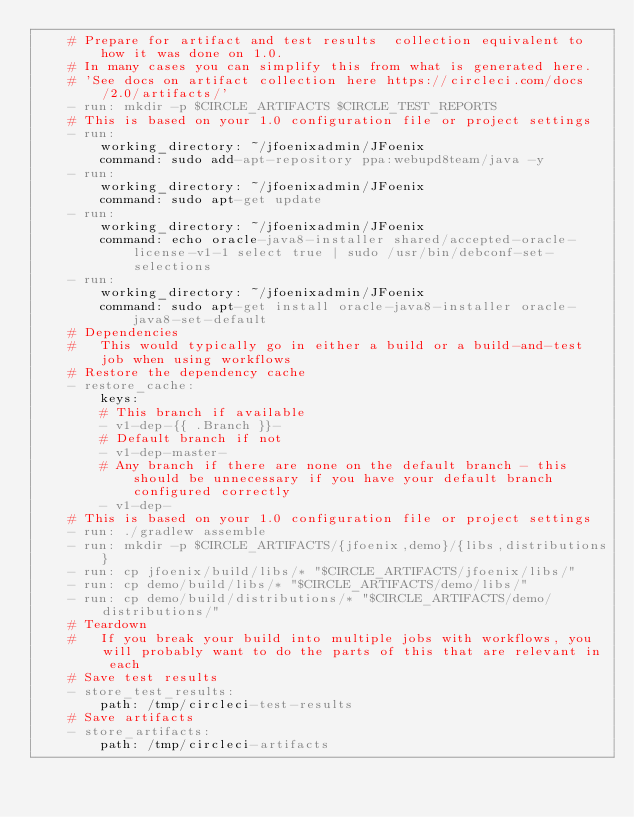<code> <loc_0><loc_0><loc_500><loc_500><_YAML_>    # Prepare for artifact and test results  collection equivalent to how it was done on 1.0.
    # In many cases you can simplify this from what is generated here.
    # 'See docs on artifact collection here https://circleci.com/docs/2.0/artifacts/'
    - run: mkdir -p $CIRCLE_ARTIFACTS $CIRCLE_TEST_REPORTS
    # This is based on your 1.0 configuration file or project settings
    - run:
        working_directory: ~/jfoenixadmin/JFoenix
        command: sudo add-apt-repository ppa:webupd8team/java -y
    - run:
        working_directory: ~/jfoenixadmin/JFoenix
        command: sudo apt-get update
    - run:
        working_directory: ~/jfoenixadmin/JFoenix
        command: echo oracle-java8-installer shared/accepted-oracle-license-v1-1 select true | sudo /usr/bin/debconf-set-selections
    - run:
        working_directory: ~/jfoenixadmin/JFoenix
        command: sudo apt-get install oracle-java8-installer oracle-java8-set-default
    # Dependencies
    #   This would typically go in either a build or a build-and-test job when using workflows
    # Restore the dependency cache
    - restore_cache:
        keys:
        # This branch if available
        - v1-dep-{{ .Branch }}-
        # Default branch if not
        - v1-dep-master-
        # Any branch if there are none on the default branch - this should be unnecessary if you have your default branch configured correctly
        - v1-dep-
    # This is based on your 1.0 configuration file or project settings
    - run: ./gradlew assemble
    - run: mkdir -p $CIRCLE_ARTIFACTS/{jfoenix,demo}/{libs,distributions}
    - run: cp jfoenix/build/libs/* "$CIRCLE_ARTIFACTS/jfoenix/libs/"
    - run: cp demo/build/libs/* "$CIRCLE_ARTIFACTS/demo/libs/"
    - run: cp demo/build/distributions/* "$CIRCLE_ARTIFACTS/demo/distributions/"
    # Teardown
    #   If you break your build into multiple jobs with workflows, you will probably want to do the parts of this that are relevant in each
    # Save test results
    - store_test_results:
        path: /tmp/circleci-test-results
    # Save artifacts
    - store_artifacts:
        path: /tmp/circleci-artifacts</code> 